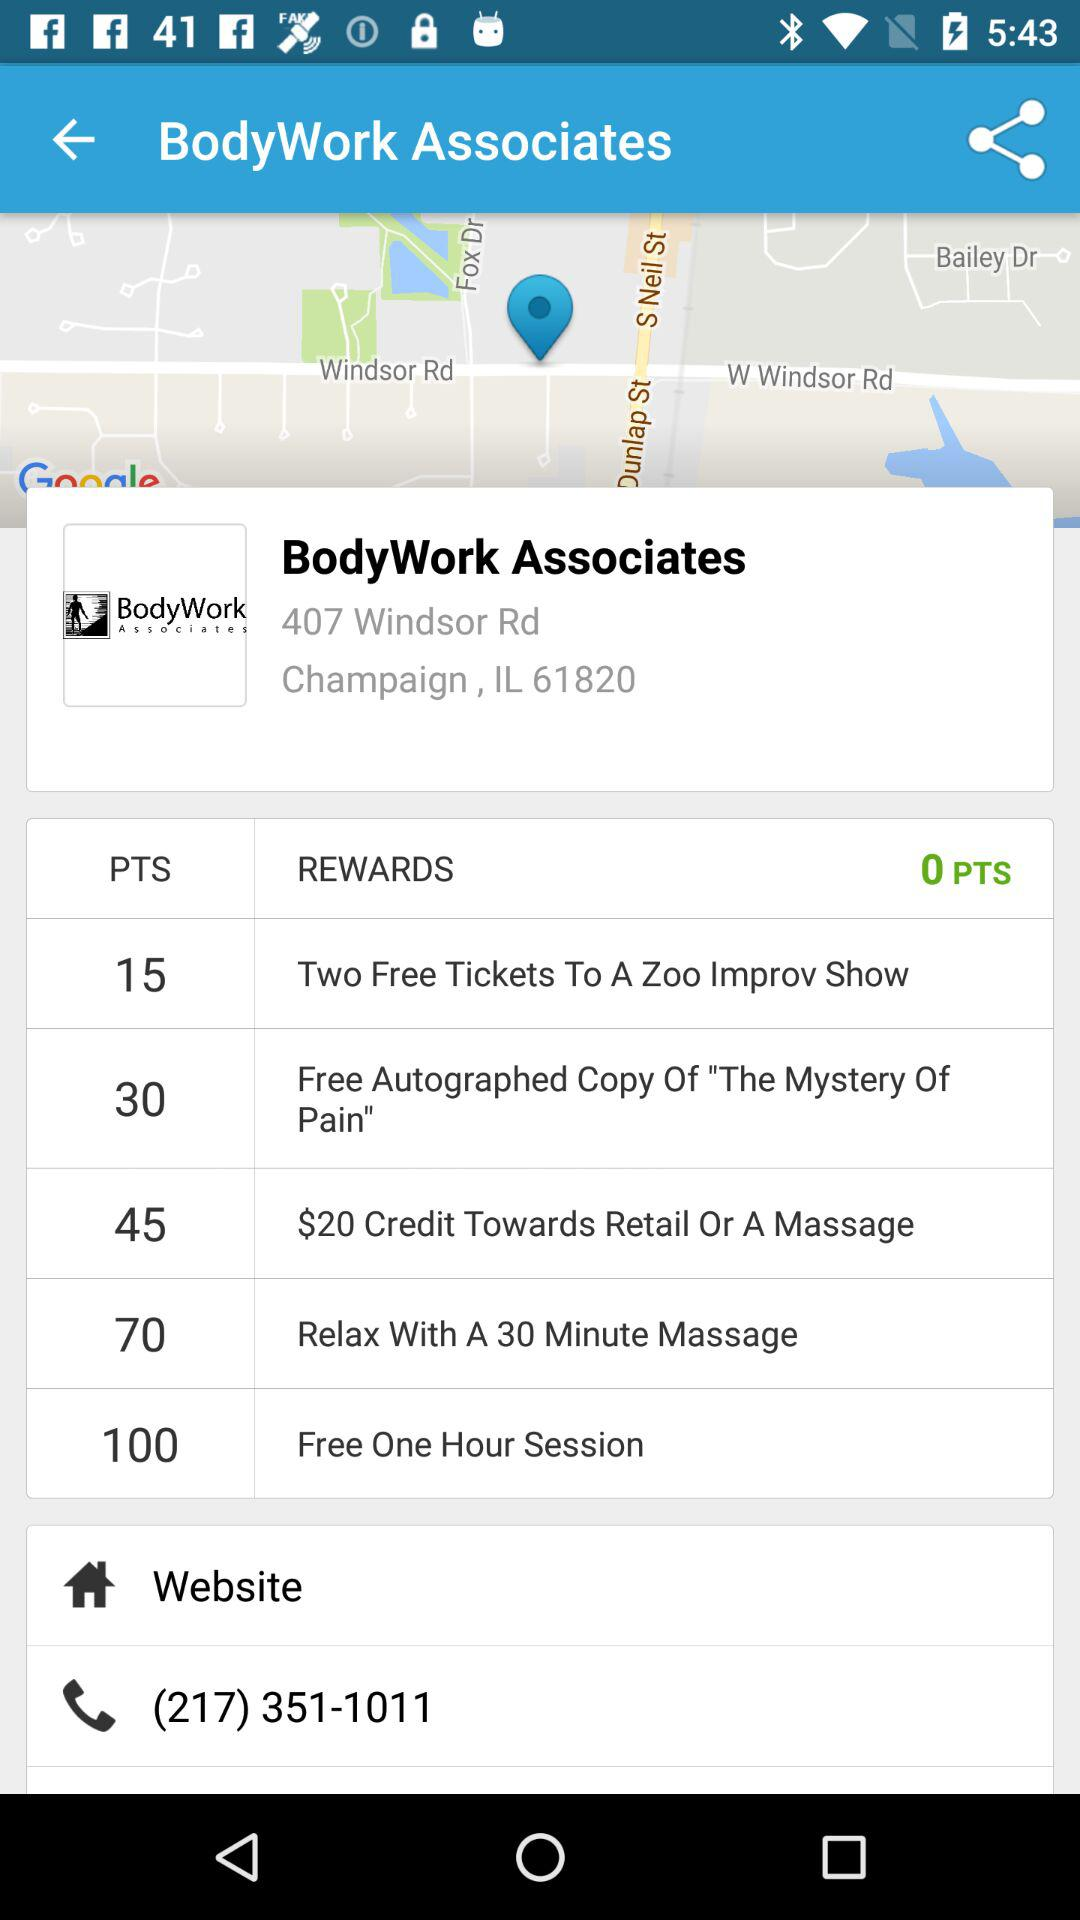What is the number of points? The number of points is 0. 